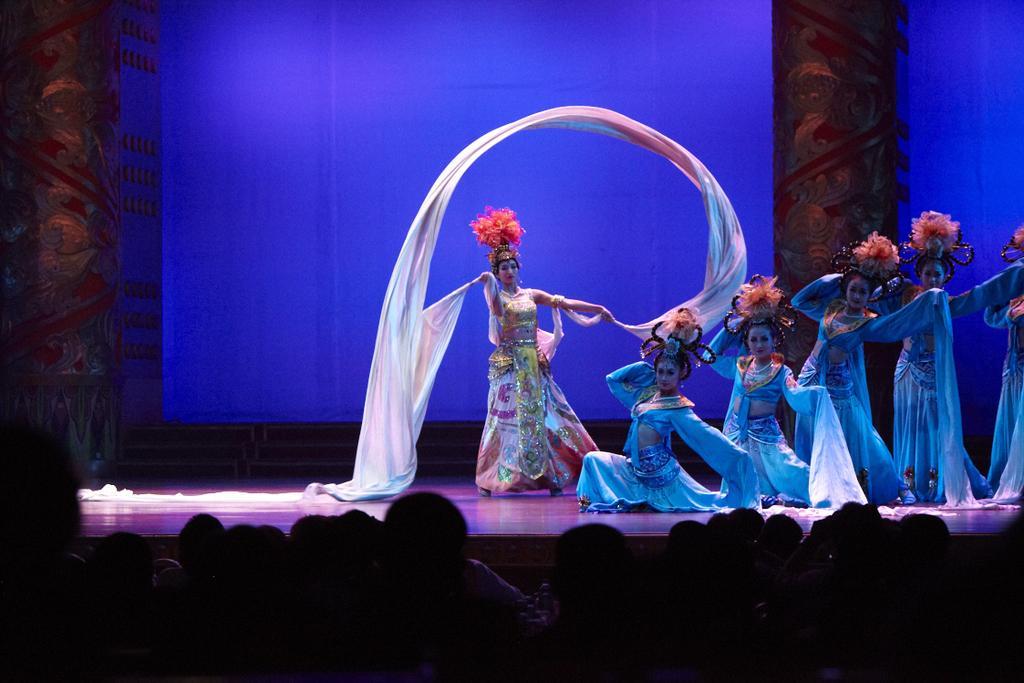Can you describe this image briefly? This picture seems to be clicked inside the hall. In the foreground we can see the group of persons and on the right we can see the group of women wearing costumes and seems to be dancing and we can see the pillars and some other objects and a white color cloth. 